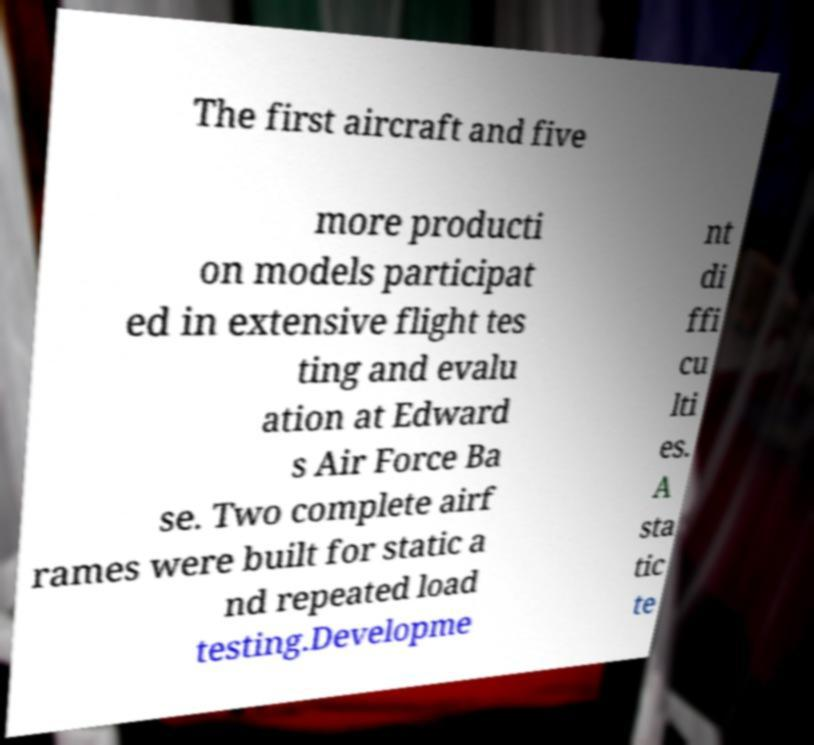For documentation purposes, I need the text within this image transcribed. Could you provide that? The first aircraft and five more producti on models participat ed in extensive flight tes ting and evalu ation at Edward s Air Force Ba se. Two complete airf rames were built for static a nd repeated load testing.Developme nt di ffi cu lti es. A sta tic te 